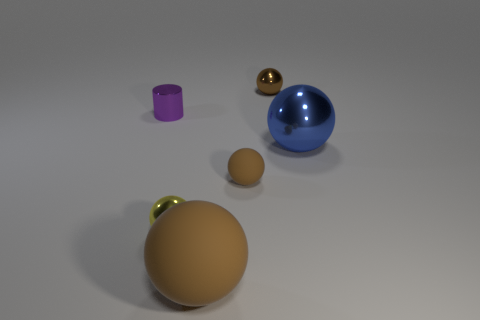Subtract all brown spheres. How many were subtracted if there are1brown spheres left? 2 Subtract all blue blocks. How many brown spheres are left? 3 Subtract 1 balls. How many balls are left? 4 Subtract all blue spheres. How many spheres are left? 4 Subtract all large shiny spheres. How many spheres are left? 4 Subtract all gray spheres. Subtract all yellow cylinders. How many spheres are left? 5 Add 4 cyan rubber balls. How many objects exist? 10 Subtract all cylinders. How many objects are left? 5 Subtract 0 yellow cylinders. How many objects are left? 6 Subtract all tiny matte spheres. Subtract all big blue things. How many objects are left? 4 